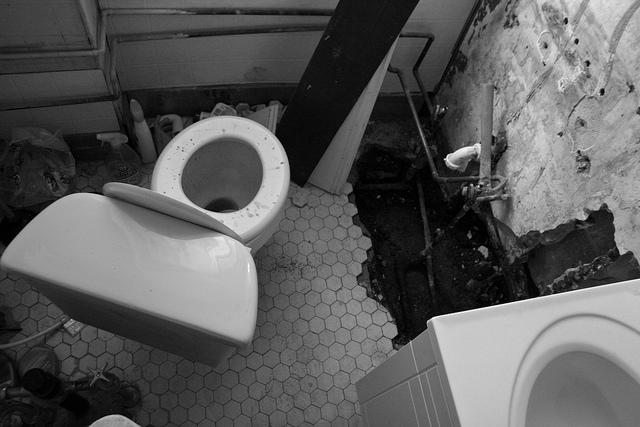Is this room functional?
Short answer required. No. Is there water in this toilet?
Be succinct. No. Is the toilet seat down?
Write a very short answer. No. Is there a spray bottle in the photo?
Quick response, please. Yes. 